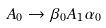Convert formula to latex. <formula><loc_0><loc_0><loc_500><loc_500>A _ { 0 } \rightarrow \beta _ { 0 } A _ { 1 } \alpha _ { 0 }</formula> 